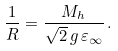<formula> <loc_0><loc_0><loc_500><loc_500>\frac { 1 } { R } = \frac { M _ { h } } { \sqrt { 2 } \, g \, \varepsilon _ { \infty } } \, .</formula> 